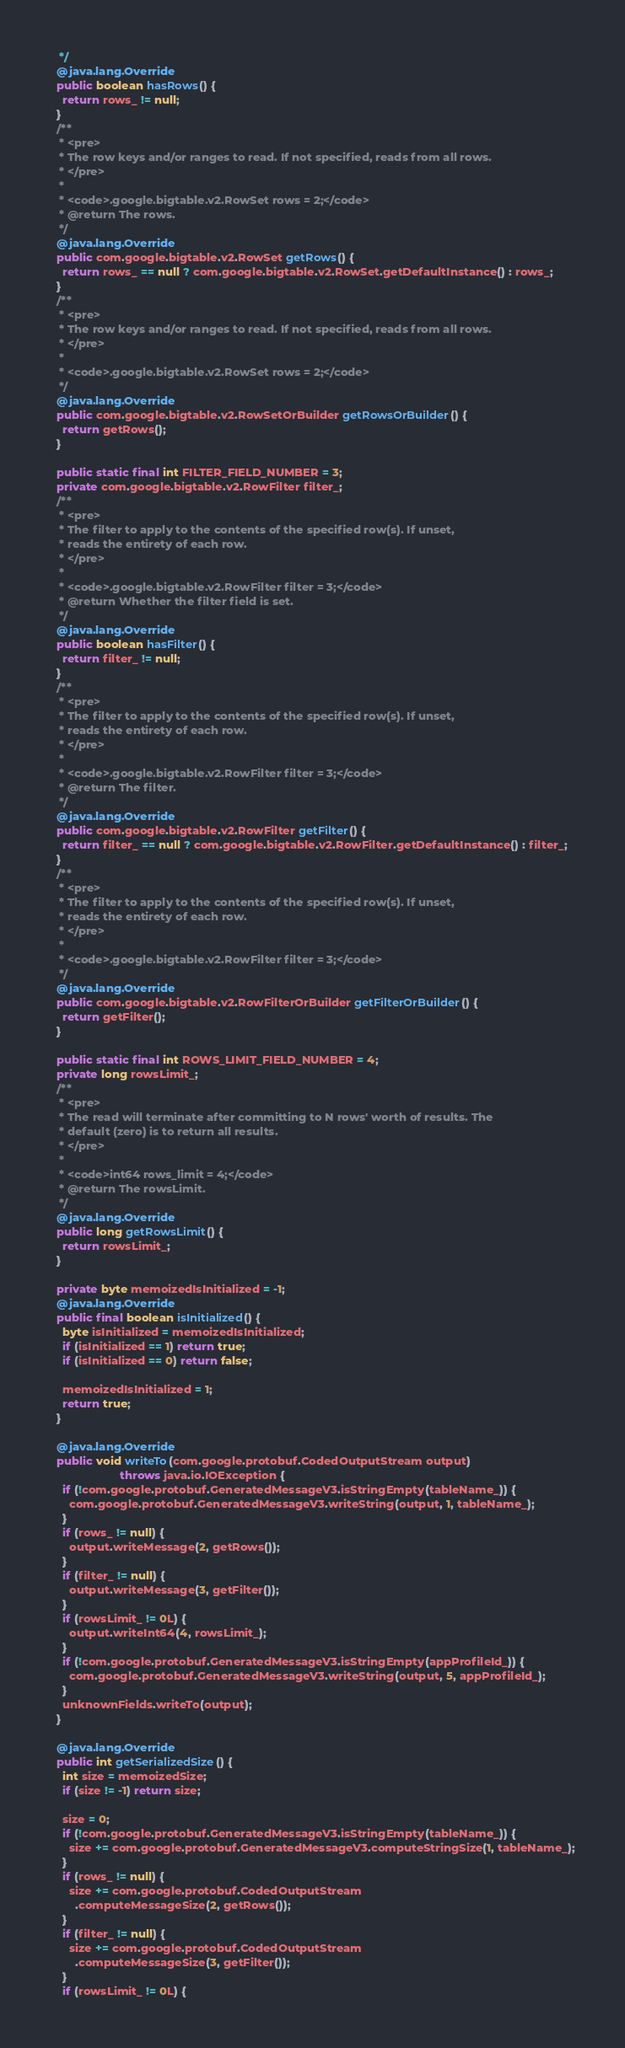Convert code to text. <code><loc_0><loc_0><loc_500><loc_500><_Java_>   */
  @java.lang.Override
  public boolean hasRows() {
    return rows_ != null;
  }
  /**
   * <pre>
   * The row keys and/or ranges to read. If not specified, reads from all rows.
   * </pre>
   *
   * <code>.google.bigtable.v2.RowSet rows = 2;</code>
   * @return The rows.
   */
  @java.lang.Override
  public com.google.bigtable.v2.RowSet getRows() {
    return rows_ == null ? com.google.bigtable.v2.RowSet.getDefaultInstance() : rows_;
  }
  /**
   * <pre>
   * The row keys and/or ranges to read. If not specified, reads from all rows.
   * </pre>
   *
   * <code>.google.bigtable.v2.RowSet rows = 2;</code>
   */
  @java.lang.Override
  public com.google.bigtable.v2.RowSetOrBuilder getRowsOrBuilder() {
    return getRows();
  }

  public static final int FILTER_FIELD_NUMBER = 3;
  private com.google.bigtable.v2.RowFilter filter_;
  /**
   * <pre>
   * The filter to apply to the contents of the specified row(s). If unset,
   * reads the entirety of each row.
   * </pre>
   *
   * <code>.google.bigtable.v2.RowFilter filter = 3;</code>
   * @return Whether the filter field is set.
   */
  @java.lang.Override
  public boolean hasFilter() {
    return filter_ != null;
  }
  /**
   * <pre>
   * The filter to apply to the contents of the specified row(s). If unset,
   * reads the entirety of each row.
   * </pre>
   *
   * <code>.google.bigtable.v2.RowFilter filter = 3;</code>
   * @return The filter.
   */
  @java.lang.Override
  public com.google.bigtable.v2.RowFilter getFilter() {
    return filter_ == null ? com.google.bigtable.v2.RowFilter.getDefaultInstance() : filter_;
  }
  /**
   * <pre>
   * The filter to apply to the contents of the specified row(s). If unset,
   * reads the entirety of each row.
   * </pre>
   *
   * <code>.google.bigtable.v2.RowFilter filter = 3;</code>
   */
  @java.lang.Override
  public com.google.bigtable.v2.RowFilterOrBuilder getFilterOrBuilder() {
    return getFilter();
  }

  public static final int ROWS_LIMIT_FIELD_NUMBER = 4;
  private long rowsLimit_;
  /**
   * <pre>
   * The read will terminate after committing to N rows' worth of results. The
   * default (zero) is to return all results.
   * </pre>
   *
   * <code>int64 rows_limit = 4;</code>
   * @return The rowsLimit.
   */
  @java.lang.Override
  public long getRowsLimit() {
    return rowsLimit_;
  }

  private byte memoizedIsInitialized = -1;
  @java.lang.Override
  public final boolean isInitialized() {
    byte isInitialized = memoizedIsInitialized;
    if (isInitialized == 1) return true;
    if (isInitialized == 0) return false;

    memoizedIsInitialized = 1;
    return true;
  }

  @java.lang.Override
  public void writeTo(com.google.protobuf.CodedOutputStream output)
                      throws java.io.IOException {
    if (!com.google.protobuf.GeneratedMessageV3.isStringEmpty(tableName_)) {
      com.google.protobuf.GeneratedMessageV3.writeString(output, 1, tableName_);
    }
    if (rows_ != null) {
      output.writeMessage(2, getRows());
    }
    if (filter_ != null) {
      output.writeMessage(3, getFilter());
    }
    if (rowsLimit_ != 0L) {
      output.writeInt64(4, rowsLimit_);
    }
    if (!com.google.protobuf.GeneratedMessageV3.isStringEmpty(appProfileId_)) {
      com.google.protobuf.GeneratedMessageV3.writeString(output, 5, appProfileId_);
    }
    unknownFields.writeTo(output);
  }

  @java.lang.Override
  public int getSerializedSize() {
    int size = memoizedSize;
    if (size != -1) return size;

    size = 0;
    if (!com.google.protobuf.GeneratedMessageV3.isStringEmpty(tableName_)) {
      size += com.google.protobuf.GeneratedMessageV3.computeStringSize(1, tableName_);
    }
    if (rows_ != null) {
      size += com.google.protobuf.CodedOutputStream
        .computeMessageSize(2, getRows());
    }
    if (filter_ != null) {
      size += com.google.protobuf.CodedOutputStream
        .computeMessageSize(3, getFilter());
    }
    if (rowsLimit_ != 0L) {</code> 